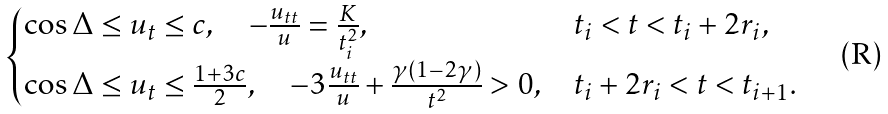<formula> <loc_0><loc_0><loc_500><loc_500>\begin{cases} \cos \Delta \leq u _ { t } \leq c , \quad - \frac { u _ { t t } } { u } = \frac { K } { t _ { i } ^ { 2 } } , & t _ { i } < t < t _ { i } + 2 r _ { i } , \\ \cos \Delta \leq u _ { t } \leq \frac { 1 + 3 c } { 2 } , \quad - 3 \frac { u _ { t t } } { u } + \frac { \gamma ( 1 - 2 \gamma ) } { t ^ { 2 } } > 0 , & t _ { i } + 2 r _ { i } < t < t _ { i + 1 } . \end{cases}</formula> 